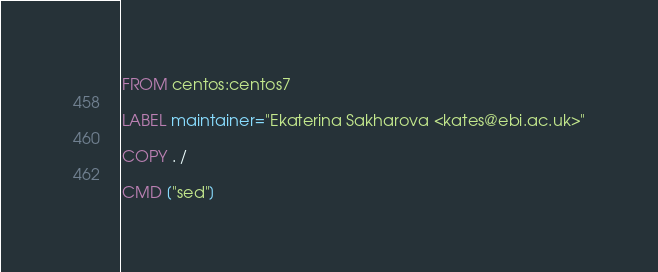Convert code to text. <code><loc_0><loc_0><loc_500><loc_500><_Dockerfile_>FROM centos:centos7

LABEL maintainer="Ekaterina Sakharova <kates@ebi.ac.uk>"

COPY . /

CMD ["sed"]
</code> 